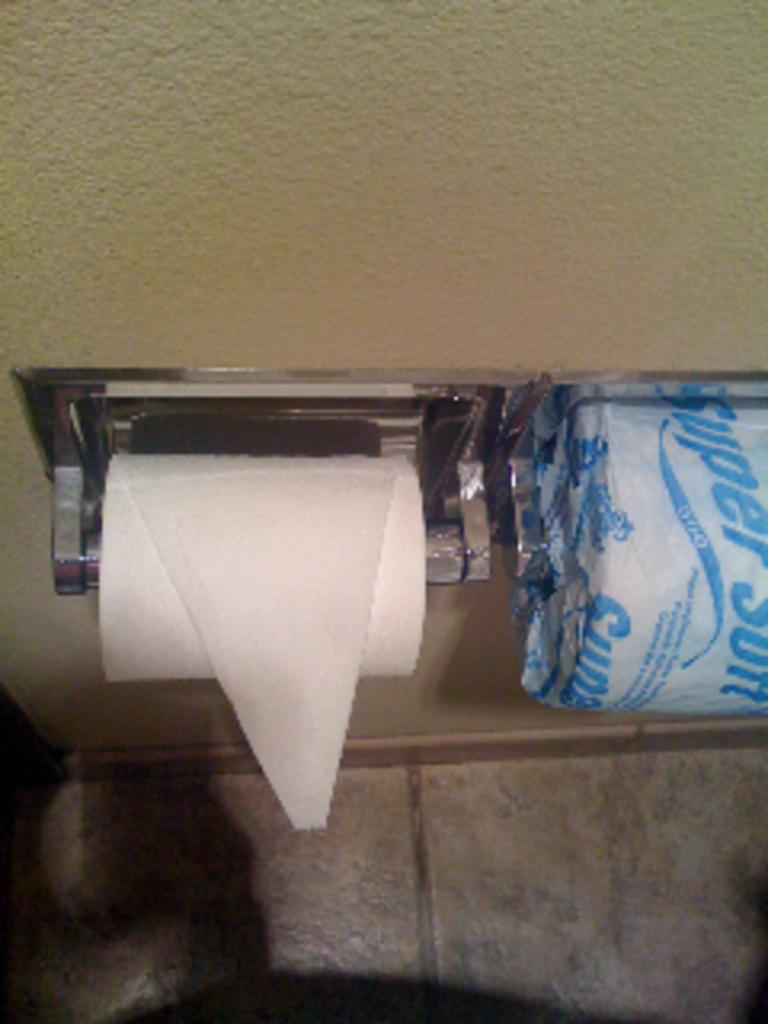Provide a one-sentence caption for the provided image. A toilet paper wrapper shows the word Super at an angle. 